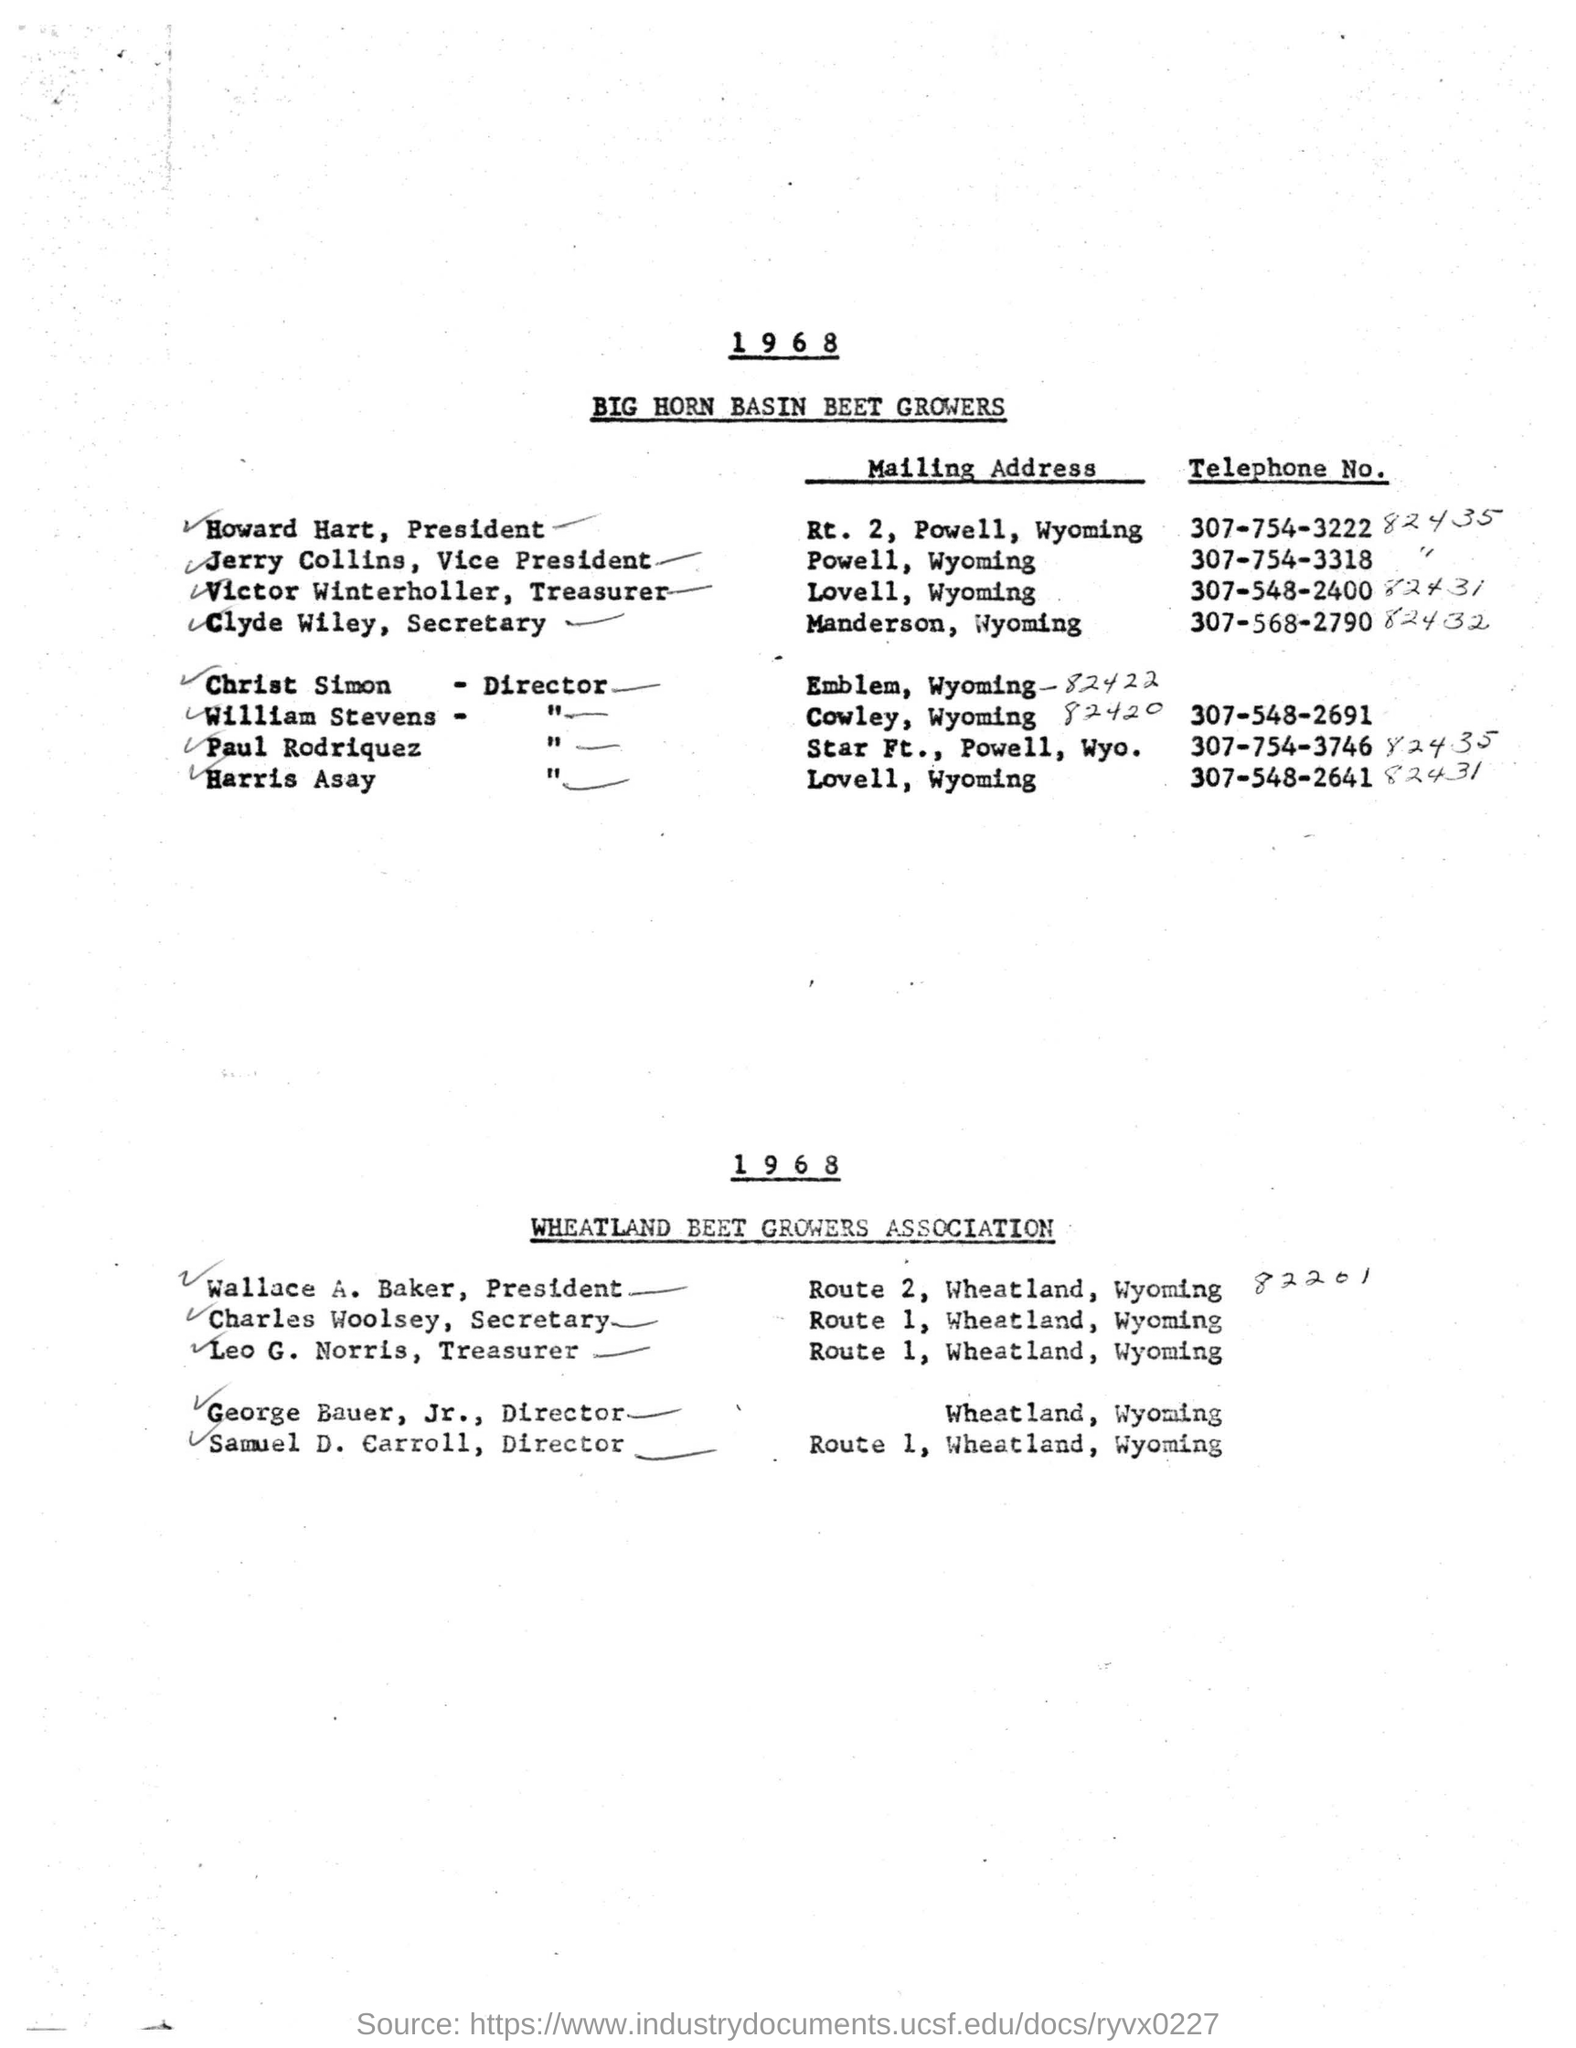Give some essential details in this illustration. The Secretary of the Wheatland Beet Growers Association is Charles Woolsey. Leo G. Norris' mailing address is Route 1, Wheatland, Wyoming. The President of the Wheatland Beet Growers Association is Wallace A. Baker. The mailing address of Howard Hart, the president, is located at Route 2, Powell, Wyoming. The growers' name is BIG HORN BASIN BEET GROWERS. 